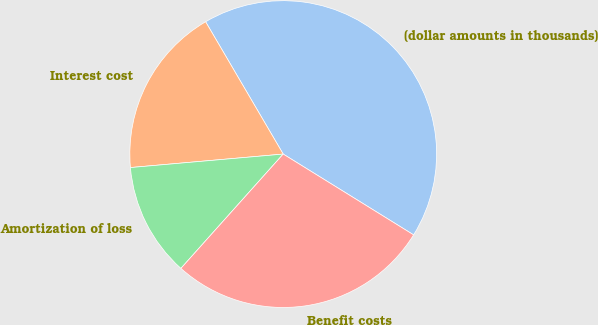<chart> <loc_0><loc_0><loc_500><loc_500><pie_chart><fcel>(dollar amounts in thousands)<fcel>Interest cost<fcel>Amortization of loss<fcel>Benefit costs<nl><fcel>42.27%<fcel>17.96%<fcel>11.98%<fcel>27.79%<nl></chart> 